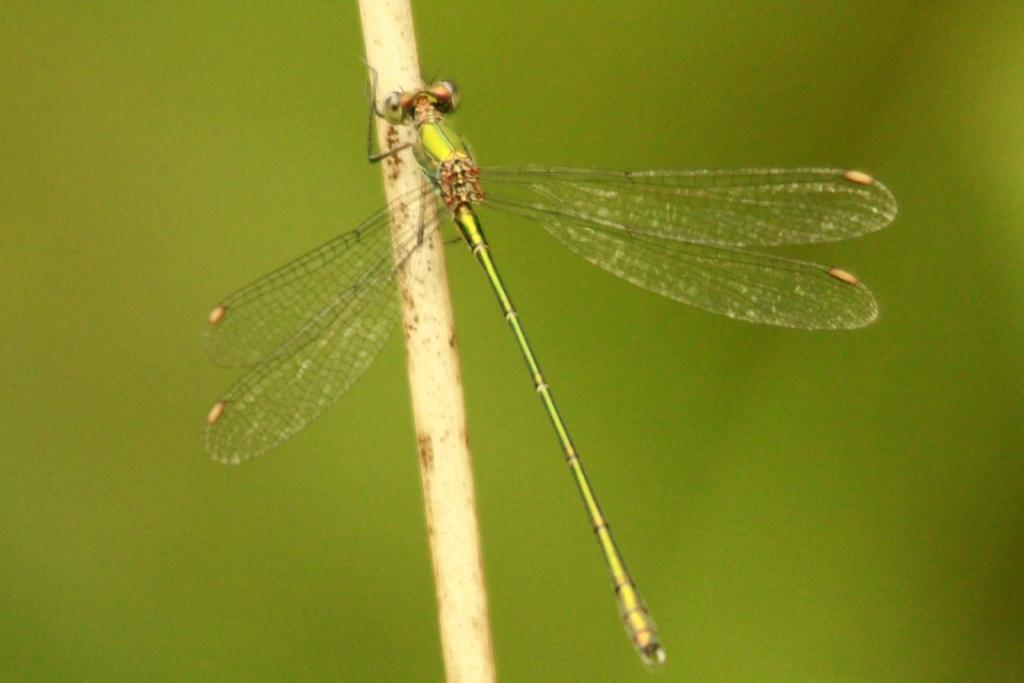What insect can be seen in the picture? There is a dragonfly in the picture. What is the color of the dragonfly? The dragonfly is green in color. What object is made of wood in the picture? There is a wooden stick in the picture. What is the dominant color in the background of the picture? The background of the picture is green. What type of smell can be detected from the dragonfly in the image? There is no indication of smell in the image, as it is a visual representation. 